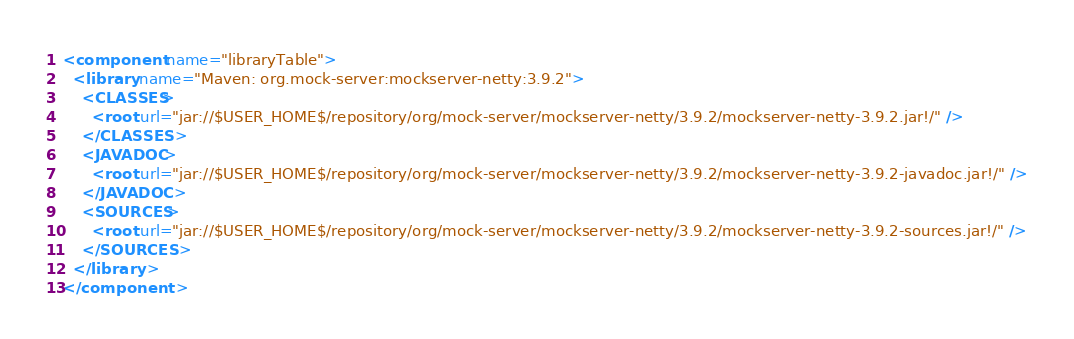Convert code to text. <code><loc_0><loc_0><loc_500><loc_500><_XML_><component name="libraryTable">
  <library name="Maven: org.mock-server:mockserver-netty:3.9.2">
    <CLASSES>
      <root url="jar://$USER_HOME$/repository/org/mock-server/mockserver-netty/3.9.2/mockserver-netty-3.9.2.jar!/" />
    </CLASSES>
    <JAVADOC>
      <root url="jar://$USER_HOME$/repository/org/mock-server/mockserver-netty/3.9.2/mockserver-netty-3.9.2-javadoc.jar!/" />
    </JAVADOC>
    <SOURCES>
      <root url="jar://$USER_HOME$/repository/org/mock-server/mockserver-netty/3.9.2/mockserver-netty-3.9.2-sources.jar!/" />
    </SOURCES>
  </library>
</component></code> 